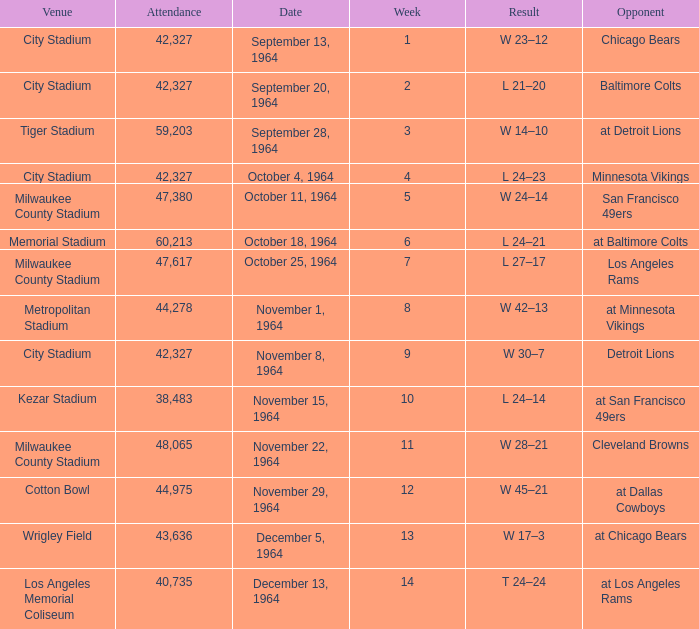What is the average week of the game on November 22, 1964 attended by 48,065? None. 